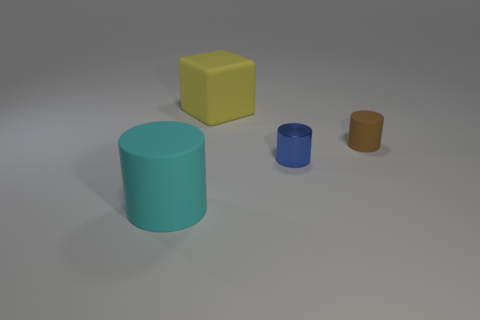Do the yellow object and the blue shiny cylinder have the same size?
Your response must be concise. No. Is there any other thing that has the same material as the small blue cylinder?
Your answer should be compact. No. How many other big objects are the same shape as the yellow matte object?
Your answer should be compact. 0. There is a yellow object that is made of the same material as the big cyan cylinder; what size is it?
Give a very brief answer. Large. What is the material of the thing that is both right of the big cyan rubber cylinder and to the left of the small metallic thing?
Your response must be concise. Rubber. How many matte objects have the same size as the metallic object?
Offer a terse response. 1. There is another tiny object that is the same shape as the brown object; what is it made of?
Make the answer very short. Metal. How many things are either small objects that are to the left of the small brown object or small things left of the small brown cylinder?
Your answer should be compact. 1. There is a cyan thing; is its shape the same as the large thing that is behind the tiny rubber cylinder?
Give a very brief answer. No. There is a large rubber object that is in front of the big rubber object behind the rubber thing that is left of the big rubber block; what shape is it?
Keep it short and to the point. Cylinder. 